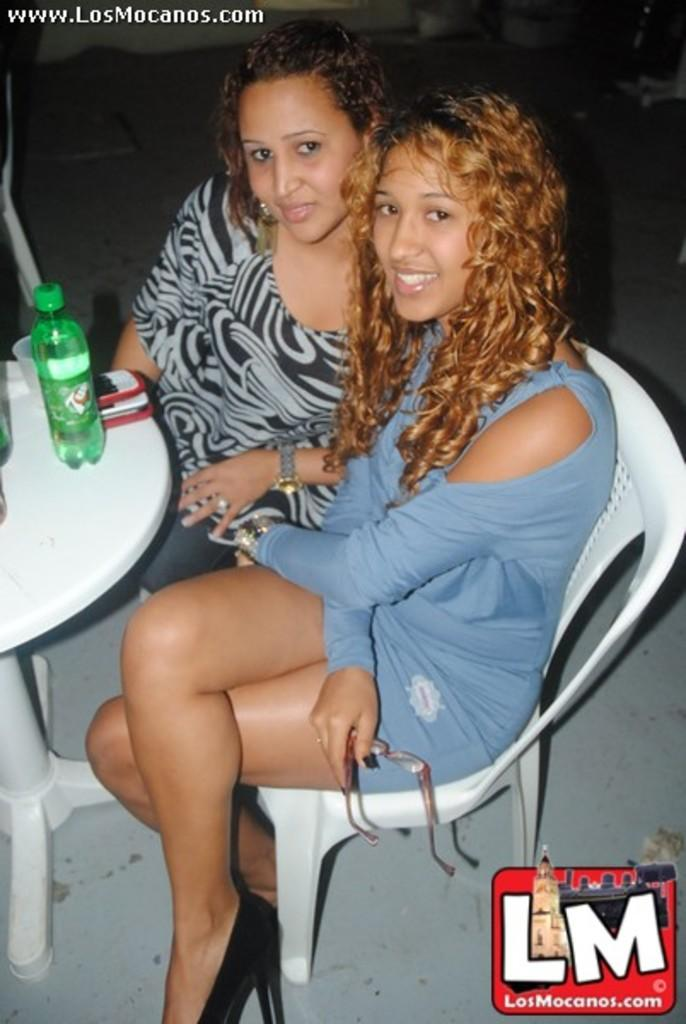How many people are in the image? There are two women in the image. What are the women doing in the image? The women are seated on chairs. What objects can be seen on the table in front of the women? There is a bottle and mobile devices on the table in front of the women. What type of activity is the turkey participating in with the women in the image? There is no turkey present in the image, so it cannot be participating in any activity with the women. 